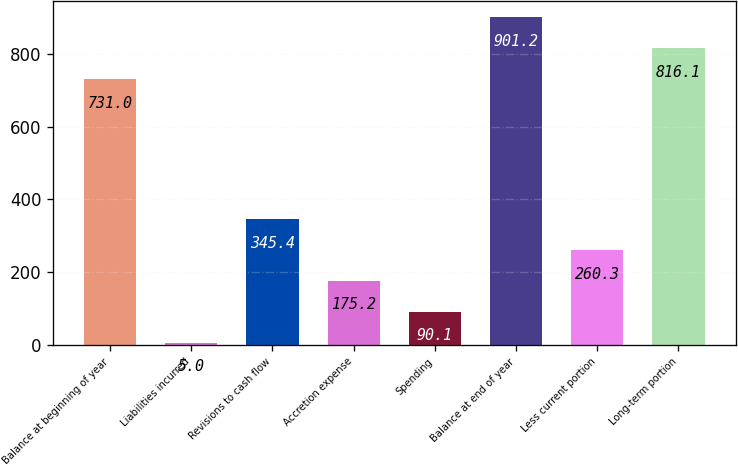<chart> <loc_0><loc_0><loc_500><loc_500><bar_chart><fcel>Balance at beginning of year<fcel>Liabilities incurred<fcel>Revisions to cash flow<fcel>Accretion expense<fcel>Spending<fcel>Balance at end of year<fcel>Less current portion<fcel>Long-term portion<nl><fcel>731<fcel>5<fcel>345.4<fcel>175.2<fcel>90.1<fcel>901.2<fcel>260.3<fcel>816.1<nl></chart> 